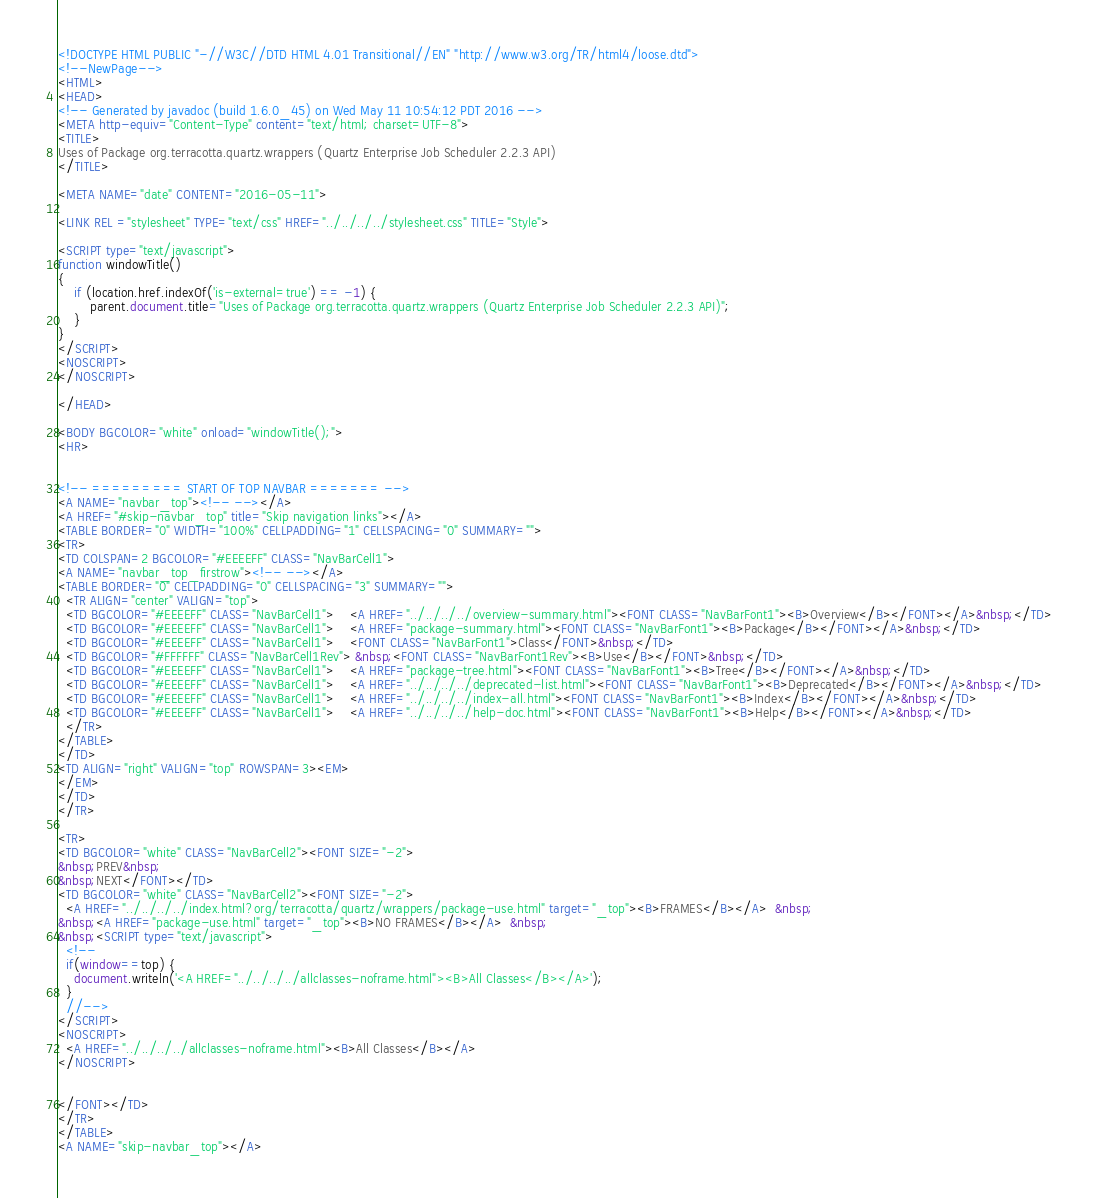<code> <loc_0><loc_0><loc_500><loc_500><_HTML_><!DOCTYPE HTML PUBLIC "-//W3C//DTD HTML 4.01 Transitional//EN" "http://www.w3.org/TR/html4/loose.dtd">
<!--NewPage-->
<HTML>
<HEAD>
<!-- Generated by javadoc (build 1.6.0_45) on Wed May 11 10:54:12 PDT 2016 -->
<META http-equiv="Content-Type" content="text/html; charset=UTF-8">
<TITLE>
Uses of Package org.terracotta.quartz.wrappers (Quartz Enterprise Job Scheduler 2.2.3 API)
</TITLE>

<META NAME="date" CONTENT="2016-05-11">

<LINK REL ="stylesheet" TYPE="text/css" HREF="../../../../stylesheet.css" TITLE="Style">

<SCRIPT type="text/javascript">
function windowTitle()
{
    if (location.href.indexOf('is-external=true') == -1) {
        parent.document.title="Uses of Package org.terracotta.quartz.wrappers (Quartz Enterprise Job Scheduler 2.2.3 API)";
    }
}
</SCRIPT>
<NOSCRIPT>
</NOSCRIPT>

</HEAD>

<BODY BGCOLOR="white" onload="windowTitle();">
<HR>


<!-- ========= START OF TOP NAVBAR ======= -->
<A NAME="navbar_top"><!-- --></A>
<A HREF="#skip-navbar_top" title="Skip navigation links"></A>
<TABLE BORDER="0" WIDTH="100%" CELLPADDING="1" CELLSPACING="0" SUMMARY="">
<TR>
<TD COLSPAN=2 BGCOLOR="#EEEEFF" CLASS="NavBarCell1">
<A NAME="navbar_top_firstrow"><!-- --></A>
<TABLE BORDER="0" CELLPADDING="0" CELLSPACING="3" SUMMARY="">
  <TR ALIGN="center" VALIGN="top">
  <TD BGCOLOR="#EEEEFF" CLASS="NavBarCell1">    <A HREF="../../../../overview-summary.html"><FONT CLASS="NavBarFont1"><B>Overview</B></FONT></A>&nbsp;</TD>
  <TD BGCOLOR="#EEEEFF" CLASS="NavBarCell1">    <A HREF="package-summary.html"><FONT CLASS="NavBarFont1"><B>Package</B></FONT></A>&nbsp;</TD>
  <TD BGCOLOR="#EEEEFF" CLASS="NavBarCell1">    <FONT CLASS="NavBarFont1">Class</FONT>&nbsp;</TD>
  <TD BGCOLOR="#FFFFFF" CLASS="NavBarCell1Rev"> &nbsp;<FONT CLASS="NavBarFont1Rev"><B>Use</B></FONT>&nbsp;</TD>
  <TD BGCOLOR="#EEEEFF" CLASS="NavBarCell1">    <A HREF="package-tree.html"><FONT CLASS="NavBarFont1"><B>Tree</B></FONT></A>&nbsp;</TD>
  <TD BGCOLOR="#EEEEFF" CLASS="NavBarCell1">    <A HREF="../../../../deprecated-list.html"><FONT CLASS="NavBarFont1"><B>Deprecated</B></FONT></A>&nbsp;</TD>
  <TD BGCOLOR="#EEEEFF" CLASS="NavBarCell1">    <A HREF="../../../../index-all.html"><FONT CLASS="NavBarFont1"><B>Index</B></FONT></A>&nbsp;</TD>
  <TD BGCOLOR="#EEEEFF" CLASS="NavBarCell1">    <A HREF="../../../../help-doc.html"><FONT CLASS="NavBarFont1"><B>Help</B></FONT></A>&nbsp;</TD>
  </TR>
</TABLE>
</TD>
<TD ALIGN="right" VALIGN="top" ROWSPAN=3><EM>
</EM>
</TD>
</TR>

<TR>
<TD BGCOLOR="white" CLASS="NavBarCell2"><FONT SIZE="-2">
&nbsp;PREV&nbsp;
&nbsp;NEXT</FONT></TD>
<TD BGCOLOR="white" CLASS="NavBarCell2"><FONT SIZE="-2">
  <A HREF="../../../../index.html?org/terracotta/quartz/wrappers/package-use.html" target="_top"><B>FRAMES</B></A>  &nbsp;
&nbsp;<A HREF="package-use.html" target="_top"><B>NO FRAMES</B></A>  &nbsp;
&nbsp;<SCRIPT type="text/javascript">
  <!--
  if(window==top) {
    document.writeln('<A HREF="../../../../allclasses-noframe.html"><B>All Classes</B></A>');
  }
  //-->
</SCRIPT>
<NOSCRIPT>
  <A HREF="../../../../allclasses-noframe.html"><B>All Classes</B></A>
</NOSCRIPT>


</FONT></TD>
</TR>
</TABLE>
<A NAME="skip-navbar_top"></A></code> 